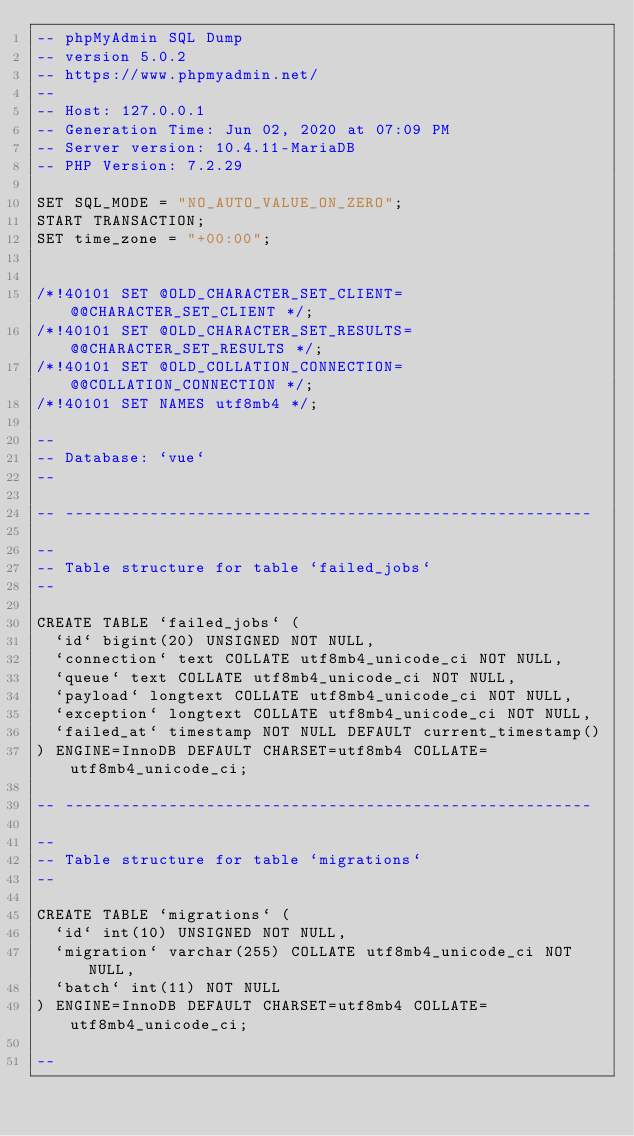Convert code to text. <code><loc_0><loc_0><loc_500><loc_500><_SQL_>-- phpMyAdmin SQL Dump
-- version 5.0.2
-- https://www.phpmyadmin.net/
--
-- Host: 127.0.0.1
-- Generation Time: Jun 02, 2020 at 07:09 PM
-- Server version: 10.4.11-MariaDB
-- PHP Version: 7.2.29

SET SQL_MODE = "NO_AUTO_VALUE_ON_ZERO";
START TRANSACTION;
SET time_zone = "+00:00";


/*!40101 SET @OLD_CHARACTER_SET_CLIENT=@@CHARACTER_SET_CLIENT */;
/*!40101 SET @OLD_CHARACTER_SET_RESULTS=@@CHARACTER_SET_RESULTS */;
/*!40101 SET @OLD_COLLATION_CONNECTION=@@COLLATION_CONNECTION */;
/*!40101 SET NAMES utf8mb4 */;

--
-- Database: `vue`
--

-- --------------------------------------------------------

--
-- Table structure for table `failed_jobs`
--

CREATE TABLE `failed_jobs` (
  `id` bigint(20) UNSIGNED NOT NULL,
  `connection` text COLLATE utf8mb4_unicode_ci NOT NULL,
  `queue` text COLLATE utf8mb4_unicode_ci NOT NULL,
  `payload` longtext COLLATE utf8mb4_unicode_ci NOT NULL,
  `exception` longtext COLLATE utf8mb4_unicode_ci NOT NULL,
  `failed_at` timestamp NOT NULL DEFAULT current_timestamp()
) ENGINE=InnoDB DEFAULT CHARSET=utf8mb4 COLLATE=utf8mb4_unicode_ci;

-- --------------------------------------------------------

--
-- Table structure for table `migrations`
--

CREATE TABLE `migrations` (
  `id` int(10) UNSIGNED NOT NULL,
  `migration` varchar(255) COLLATE utf8mb4_unicode_ci NOT NULL,
  `batch` int(11) NOT NULL
) ENGINE=InnoDB DEFAULT CHARSET=utf8mb4 COLLATE=utf8mb4_unicode_ci;

--</code> 